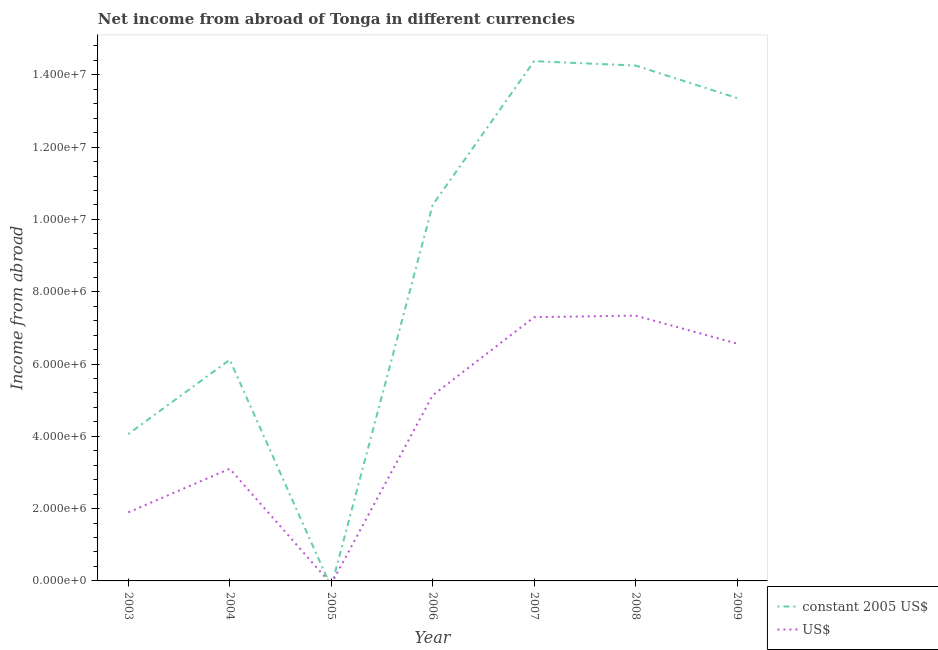Does the line corresponding to income from abroad in us$ intersect with the line corresponding to income from abroad in constant 2005 us$?
Offer a terse response. Yes. What is the income from abroad in constant 2005 us$ in 2007?
Give a very brief answer. 1.44e+07. Across all years, what is the maximum income from abroad in us$?
Offer a very short reply. 7.34e+06. Across all years, what is the minimum income from abroad in us$?
Your answer should be very brief. 0. What is the total income from abroad in us$ in the graph?
Provide a short and direct response. 3.13e+07. What is the difference between the income from abroad in us$ in 2003 and that in 2008?
Your answer should be very brief. -5.44e+06. What is the difference between the income from abroad in us$ in 2006 and the income from abroad in constant 2005 us$ in 2003?
Ensure brevity in your answer.  1.07e+06. What is the average income from abroad in constant 2005 us$ per year?
Your answer should be very brief. 8.94e+06. In the year 2008, what is the difference between the income from abroad in constant 2005 us$ and income from abroad in us$?
Make the answer very short. 6.92e+06. What is the ratio of the income from abroad in constant 2005 us$ in 2007 to that in 2008?
Your answer should be very brief. 1.01. What is the difference between the highest and the second highest income from abroad in us$?
Your answer should be very brief. 4.45e+04. What is the difference between the highest and the lowest income from abroad in us$?
Keep it short and to the point. 7.34e+06. In how many years, is the income from abroad in constant 2005 us$ greater than the average income from abroad in constant 2005 us$ taken over all years?
Make the answer very short. 4. Is the income from abroad in us$ strictly greater than the income from abroad in constant 2005 us$ over the years?
Offer a terse response. No. How many lines are there?
Provide a succinct answer. 2. What is the difference between two consecutive major ticks on the Y-axis?
Provide a succinct answer. 2.00e+06. Does the graph contain grids?
Keep it short and to the point. No. Where does the legend appear in the graph?
Keep it short and to the point. Bottom right. How many legend labels are there?
Provide a short and direct response. 2. What is the title of the graph?
Offer a very short reply. Net income from abroad of Tonga in different currencies. What is the label or title of the X-axis?
Your response must be concise. Year. What is the label or title of the Y-axis?
Your response must be concise. Income from abroad. What is the Income from abroad of constant 2005 US$ in 2003?
Your answer should be very brief. 4.06e+06. What is the Income from abroad in US$ in 2003?
Give a very brief answer. 1.90e+06. What is the Income from abroad of constant 2005 US$ in 2004?
Your answer should be very brief. 6.12e+06. What is the Income from abroad of US$ in 2004?
Keep it short and to the point. 3.10e+06. What is the Income from abroad in constant 2005 US$ in 2006?
Provide a succinct answer. 1.04e+07. What is the Income from abroad of US$ in 2006?
Your response must be concise. 5.13e+06. What is the Income from abroad in constant 2005 US$ in 2007?
Offer a terse response. 1.44e+07. What is the Income from abroad in US$ in 2007?
Your response must be concise. 7.29e+06. What is the Income from abroad in constant 2005 US$ in 2008?
Your answer should be very brief. 1.43e+07. What is the Income from abroad in US$ in 2008?
Ensure brevity in your answer.  7.34e+06. What is the Income from abroad of constant 2005 US$ in 2009?
Keep it short and to the point. 1.34e+07. What is the Income from abroad in US$ in 2009?
Offer a terse response. 6.57e+06. Across all years, what is the maximum Income from abroad in constant 2005 US$?
Provide a succinct answer. 1.44e+07. Across all years, what is the maximum Income from abroad of US$?
Give a very brief answer. 7.34e+06. Across all years, what is the minimum Income from abroad of constant 2005 US$?
Offer a very short reply. 0. Across all years, what is the minimum Income from abroad of US$?
Give a very brief answer. 0. What is the total Income from abroad in constant 2005 US$ in the graph?
Offer a very short reply. 6.26e+07. What is the total Income from abroad in US$ in the graph?
Make the answer very short. 3.13e+07. What is the difference between the Income from abroad of constant 2005 US$ in 2003 and that in 2004?
Provide a short and direct response. -2.05e+06. What is the difference between the Income from abroad of US$ in 2003 and that in 2004?
Your response must be concise. -1.21e+06. What is the difference between the Income from abroad of constant 2005 US$ in 2003 and that in 2006?
Your answer should be compact. -6.34e+06. What is the difference between the Income from abroad of US$ in 2003 and that in 2006?
Offer a very short reply. -3.24e+06. What is the difference between the Income from abroad of constant 2005 US$ in 2003 and that in 2007?
Offer a very short reply. -1.03e+07. What is the difference between the Income from abroad in US$ in 2003 and that in 2007?
Keep it short and to the point. -5.40e+06. What is the difference between the Income from abroad of constant 2005 US$ in 2003 and that in 2008?
Your answer should be compact. -1.02e+07. What is the difference between the Income from abroad of US$ in 2003 and that in 2008?
Offer a terse response. -5.44e+06. What is the difference between the Income from abroad of constant 2005 US$ in 2003 and that in 2009?
Your response must be concise. -9.29e+06. What is the difference between the Income from abroad of US$ in 2003 and that in 2009?
Keep it short and to the point. -4.67e+06. What is the difference between the Income from abroad of constant 2005 US$ in 2004 and that in 2006?
Offer a very short reply. -4.28e+06. What is the difference between the Income from abroad of US$ in 2004 and that in 2006?
Make the answer very short. -2.03e+06. What is the difference between the Income from abroad in constant 2005 US$ in 2004 and that in 2007?
Provide a short and direct response. -8.26e+06. What is the difference between the Income from abroad of US$ in 2004 and that in 2007?
Offer a very short reply. -4.19e+06. What is the difference between the Income from abroad in constant 2005 US$ in 2004 and that in 2008?
Your response must be concise. -8.14e+06. What is the difference between the Income from abroad of US$ in 2004 and that in 2008?
Ensure brevity in your answer.  -4.24e+06. What is the difference between the Income from abroad in constant 2005 US$ in 2004 and that in 2009?
Keep it short and to the point. -7.24e+06. What is the difference between the Income from abroad in US$ in 2004 and that in 2009?
Give a very brief answer. -3.46e+06. What is the difference between the Income from abroad in constant 2005 US$ in 2006 and that in 2007?
Offer a very short reply. -3.98e+06. What is the difference between the Income from abroad in US$ in 2006 and that in 2007?
Provide a short and direct response. -2.16e+06. What is the difference between the Income from abroad in constant 2005 US$ in 2006 and that in 2008?
Provide a succinct answer. -3.86e+06. What is the difference between the Income from abroad in US$ in 2006 and that in 2008?
Keep it short and to the point. -2.21e+06. What is the difference between the Income from abroad in constant 2005 US$ in 2006 and that in 2009?
Provide a succinct answer. -2.96e+06. What is the difference between the Income from abroad in US$ in 2006 and that in 2009?
Provide a succinct answer. -1.43e+06. What is the difference between the Income from abroad of constant 2005 US$ in 2007 and that in 2008?
Make the answer very short. 1.21e+05. What is the difference between the Income from abroad of US$ in 2007 and that in 2008?
Make the answer very short. -4.45e+04. What is the difference between the Income from abroad of constant 2005 US$ in 2007 and that in 2009?
Ensure brevity in your answer.  1.02e+06. What is the difference between the Income from abroad of US$ in 2007 and that in 2009?
Your answer should be compact. 7.29e+05. What is the difference between the Income from abroad in constant 2005 US$ in 2008 and that in 2009?
Provide a short and direct response. 8.98e+05. What is the difference between the Income from abroad of US$ in 2008 and that in 2009?
Ensure brevity in your answer.  7.74e+05. What is the difference between the Income from abroad in constant 2005 US$ in 2003 and the Income from abroad in US$ in 2004?
Offer a terse response. 9.60e+05. What is the difference between the Income from abroad of constant 2005 US$ in 2003 and the Income from abroad of US$ in 2006?
Your response must be concise. -1.07e+06. What is the difference between the Income from abroad in constant 2005 US$ in 2003 and the Income from abroad in US$ in 2007?
Keep it short and to the point. -3.23e+06. What is the difference between the Income from abroad in constant 2005 US$ in 2003 and the Income from abroad in US$ in 2008?
Keep it short and to the point. -3.28e+06. What is the difference between the Income from abroad of constant 2005 US$ in 2003 and the Income from abroad of US$ in 2009?
Give a very brief answer. -2.50e+06. What is the difference between the Income from abroad of constant 2005 US$ in 2004 and the Income from abroad of US$ in 2006?
Your answer should be very brief. 9.84e+05. What is the difference between the Income from abroad of constant 2005 US$ in 2004 and the Income from abroad of US$ in 2007?
Provide a succinct answer. -1.18e+06. What is the difference between the Income from abroad in constant 2005 US$ in 2004 and the Income from abroad in US$ in 2008?
Offer a very short reply. -1.22e+06. What is the difference between the Income from abroad in constant 2005 US$ in 2004 and the Income from abroad in US$ in 2009?
Your answer should be very brief. -4.49e+05. What is the difference between the Income from abroad in constant 2005 US$ in 2006 and the Income from abroad in US$ in 2007?
Make the answer very short. 3.10e+06. What is the difference between the Income from abroad in constant 2005 US$ in 2006 and the Income from abroad in US$ in 2008?
Offer a terse response. 3.06e+06. What is the difference between the Income from abroad in constant 2005 US$ in 2006 and the Income from abroad in US$ in 2009?
Ensure brevity in your answer.  3.83e+06. What is the difference between the Income from abroad in constant 2005 US$ in 2007 and the Income from abroad in US$ in 2008?
Give a very brief answer. 7.04e+06. What is the difference between the Income from abroad of constant 2005 US$ in 2007 and the Income from abroad of US$ in 2009?
Your answer should be very brief. 7.81e+06. What is the difference between the Income from abroad of constant 2005 US$ in 2008 and the Income from abroad of US$ in 2009?
Your answer should be very brief. 7.69e+06. What is the average Income from abroad in constant 2005 US$ per year?
Provide a succinct answer. 8.94e+06. What is the average Income from abroad in US$ per year?
Your answer should be compact. 4.48e+06. In the year 2003, what is the difference between the Income from abroad of constant 2005 US$ and Income from abroad of US$?
Your answer should be very brief. 2.17e+06. In the year 2004, what is the difference between the Income from abroad in constant 2005 US$ and Income from abroad in US$?
Offer a very short reply. 3.01e+06. In the year 2006, what is the difference between the Income from abroad of constant 2005 US$ and Income from abroad of US$?
Keep it short and to the point. 5.27e+06. In the year 2007, what is the difference between the Income from abroad of constant 2005 US$ and Income from abroad of US$?
Your response must be concise. 7.08e+06. In the year 2008, what is the difference between the Income from abroad in constant 2005 US$ and Income from abroad in US$?
Give a very brief answer. 6.92e+06. In the year 2009, what is the difference between the Income from abroad of constant 2005 US$ and Income from abroad of US$?
Give a very brief answer. 6.79e+06. What is the ratio of the Income from abroad of constant 2005 US$ in 2003 to that in 2004?
Your answer should be compact. 0.66. What is the ratio of the Income from abroad in US$ in 2003 to that in 2004?
Give a very brief answer. 0.61. What is the ratio of the Income from abroad in constant 2005 US$ in 2003 to that in 2006?
Your response must be concise. 0.39. What is the ratio of the Income from abroad of US$ in 2003 to that in 2006?
Keep it short and to the point. 0.37. What is the ratio of the Income from abroad of constant 2005 US$ in 2003 to that in 2007?
Offer a terse response. 0.28. What is the ratio of the Income from abroad of US$ in 2003 to that in 2007?
Your answer should be compact. 0.26. What is the ratio of the Income from abroad in constant 2005 US$ in 2003 to that in 2008?
Your answer should be compact. 0.28. What is the ratio of the Income from abroad of US$ in 2003 to that in 2008?
Ensure brevity in your answer.  0.26. What is the ratio of the Income from abroad of constant 2005 US$ in 2003 to that in 2009?
Offer a terse response. 0.3. What is the ratio of the Income from abroad of US$ in 2003 to that in 2009?
Keep it short and to the point. 0.29. What is the ratio of the Income from abroad of constant 2005 US$ in 2004 to that in 2006?
Provide a succinct answer. 0.59. What is the ratio of the Income from abroad of US$ in 2004 to that in 2006?
Give a very brief answer. 0.6. What is the ratio of the Income from abroad in constant 2005 US$ in 2004 to that in 2007?
Offer a terse response. 0.43. What is the ratio of the Income from abroad of US$ in 2004 to that in 2007?
Provide a short and direct response. 0.43. What is the ratio of the Income from abroad in constant 2005 US$ in 2004 to that in 2008?
Offer a terse response. 0.43. What is the ratio of the Income from abroad in US$ in 2004 to that in 2008?
Offer a very short reply. 0.42. What is the ratio of the Income from abroad of constant 2005 US$ in 2004 to that in 2009?
Offer a terse response. 0.46. What is the ratio of the Income from abroad of US$ in 2004 to that in 2009?
Make the answer very short. 0.47. What is the ratio of the Income from abroad in constant 2005 US$ in 2006 to that in 2007?
Offer a very short reply. 0.72. What is the ratio of the Income from abroad in US$ in 2006 to that in 2007?
Give a very brief answer. 0.7. What is the ratio of the Income from abroad of constant 2005 US$ in 2006 to that in 2008?
Ensure brevity in your answer.  0.73. What is the ratio of the Income from abroad of US$ in 2006 to that in 2008?
Make the answer very short. 0.7. What is the ratio of the Income from abroad of constant 2005 US$ in 2006 to that in 2009?
Give a very brief answer. 0.78. What is the ratio of the Income from abroad of US$ in 2006 to that in 2009?
Provide a short and direct response. 0.78. What is the ratio of the Income from abroad of constant 2005 US$ in 2007 to that in 2008?
Keep it short and to the point. 1.01. What is the ratio of the Income from abroad of constant 2005 US$ in 2007 to that in 2009?
Your response must be concise. 1.08. What is the ratio of the Income from abroad of US$ in 2007 to that in 2009?
Keep it short and to the point. 1.11. What is the ratio of the Income from abroad in constant 2005 US$ in 2008 to that in 2009?
Offer a very short reply. 1.07. What is the ratio of the Income from abroad in US$ in 2008 to that in 2009?
Give a very brief answer. 1.12. What is the difference between the highest and the second highest Income from abroad of constant 2005 US$?
Ensure brevity in your answer.  1.21e+05. What is the difference between the highest and the second highest Income from abroad in US$?
Your answer should be very brief. 4.45e+04. What is the difference between the highest and the lowest Income from abroad in constant 2005 US$?
Your answer should be very brief. 1.44e+07. What is the difference between the highest and the lowest Income from abroad of US$?
Ensure brevity in your answer.  7.34e+06. 